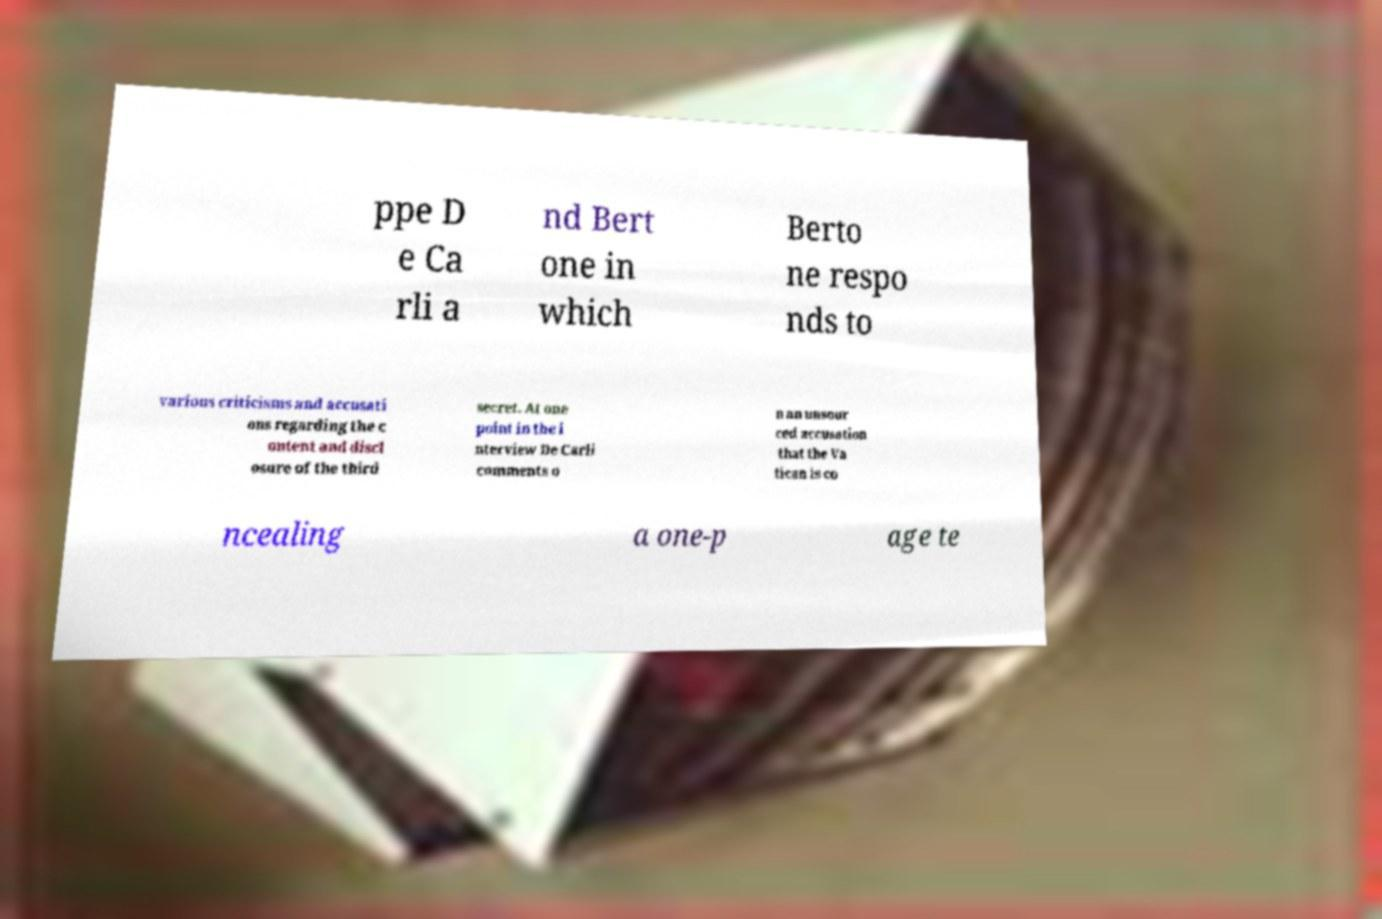Please identify and transcribe the text found in this image. ppe D e Ca rli a nd Bert one in which Berto ne respo nds to various criticisms and accusati ons regarding the c ontent and discl osure of the third secret. At one point in the i nterview De Carli comments o n an unsour ced accusation that the Va tican is co ncealing a one-p age te 